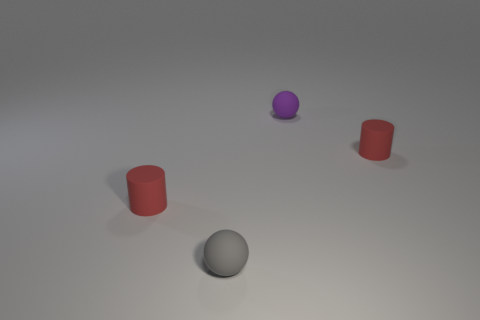Are there fewer purple matte objects on the right side of the purple sphere than tiny matte cylinders that are to the left of the gray matte object?
Your answer should be compact. Yes. Is the number of cylinders to the left of the purple object less than the number of balls?
Ensure brevity in your answer.  Yes. There is a small cylinder right of the gray sphere; what material is it?
Offer a terse response. Rubber. What number of other things are there of the same size as the gray ball?
Provide a short and direct response. 3. Is the number of brown rubber blocks less than the number of red matte cylinders?
Provide a short and direct response. Yes. What is the shape of the gray matte thing?
Your response must be concise. Sphere. What is the color of the matte cylinder to the left of the gray matte ball?
Make the answer very short. Red. How many other tiny purple spheres are the same material as the purple ball?
Ensure brevity in your answer.  0. There is a tiny gray object that is to the left of the purple matte thing; is it the same shape as the purple rubber thing?
Keep it short and to the point. Yes. What number of things are tiny rubber cylinders that are to the left of the purple sphere or rubber cylinders?
Give a very brief answer. 2. 